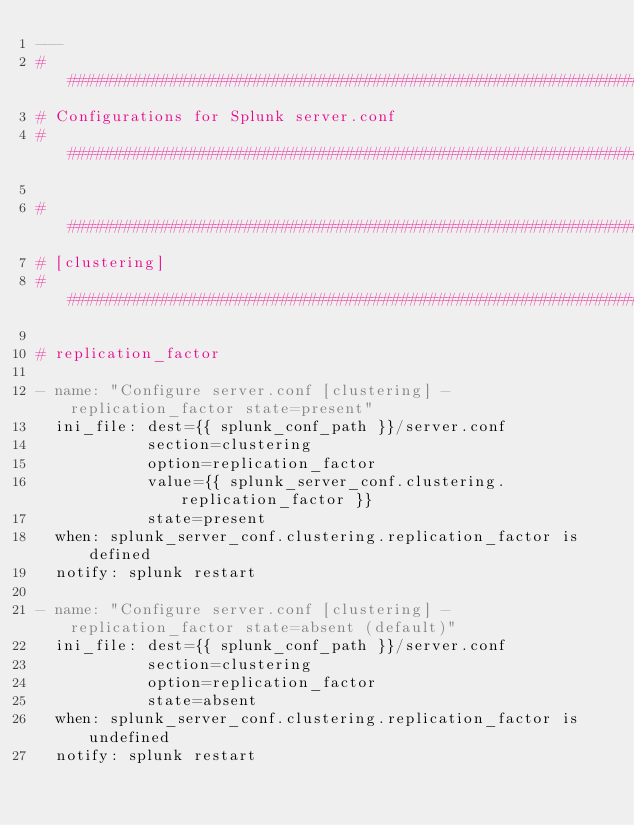<code> <loc_0><loc_0><loc_500><loc_500><_YAML_>---
#####################################################################################################################
# Configurations for Splunk server.conf
#####################################################################################################################

#####################################################################################################################
# [clustering]
#####################################################################################################################

# replication_factor

- name: "Configure server.conf [clustering] - replication_factor state=present"
  ini_file: dest={{ splunk_conf_path }}/server.conf
            section=clustering
            option=replication_factor
            value={{ splunk_server_conf.clustering.replication_factor }}
            state=present
  when: splunk_server_conf.clustering.replication_factor is defined
  notify: splunk restart

- name: "Configure server.conf [clustering] - replication_factor state=absent (default)"
  ini_file: dest={{ splunk_conf_path }}/server.conf
            section=clustering
            option=replication_factor
            state=absent
  when: splunk_server_conf.clustering.replication_factor is undefined
  notify: splunk restart
</code> 